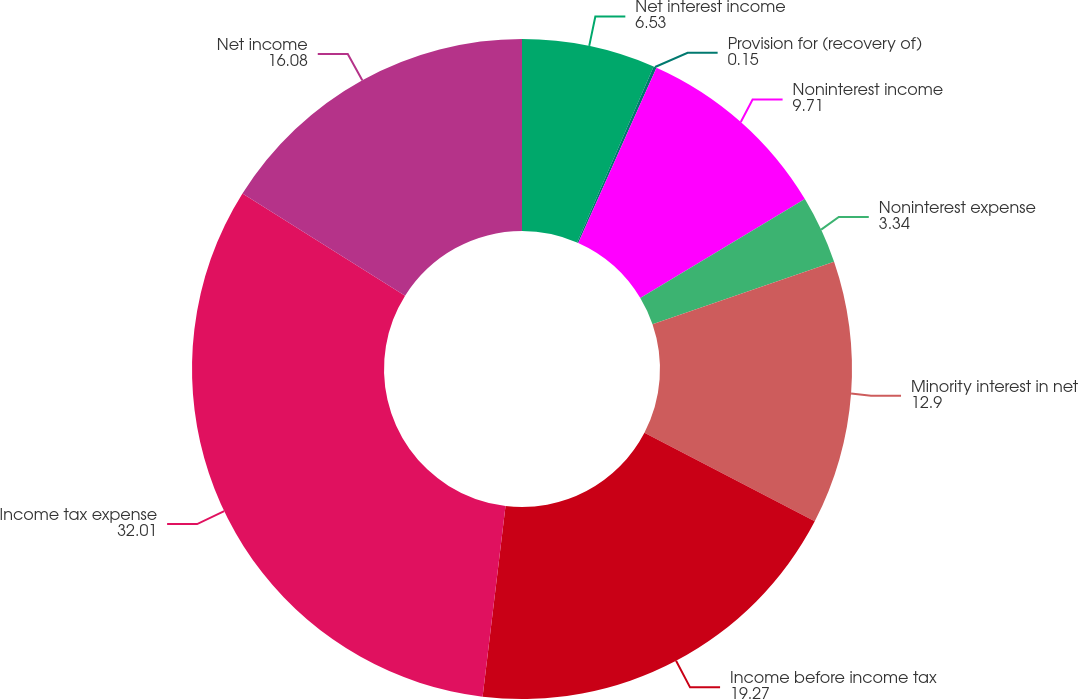<chart> <loc_0><loc_0><loc_500><loc_500><pie_chart><fcel>Net interest income<fcel>Provision for (recovery of)<fcel>Noninterest income<fcel>Noninterest expense<fcel>Minority interest in net<fcel>Income before income tax<fcel>Income tax expense<fcel>Net income<nl><fcel>6.53%<fcel>0.15%<fcel>9.71%<fcel>3.34%<fcel>12.9%<fcel>19.27%<fcel>32.01%<fcel>16.08%<nl></chart> 